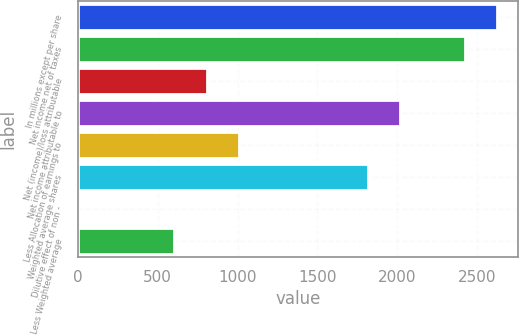<chart> <loc_0><loc_0><loc_500><loc_500><bar_chart><fcel>In millions except per share<fcel>Net income net of taxes<fcel>Net (income)/loss attributable<fcel>Net income attributable to<fcel>Less Allocation of earnings to<fcel>Weighted average shares<fcel>Dilutive effect of non -<fcel>Less Weighted average<nl><fcel>2621.95<fcel>2420.3<fcel>807.1<fcel>2017<fcel>1008.75<fcel>1815.35<fcel>0.5<fcel>605.45<nl></chart> 